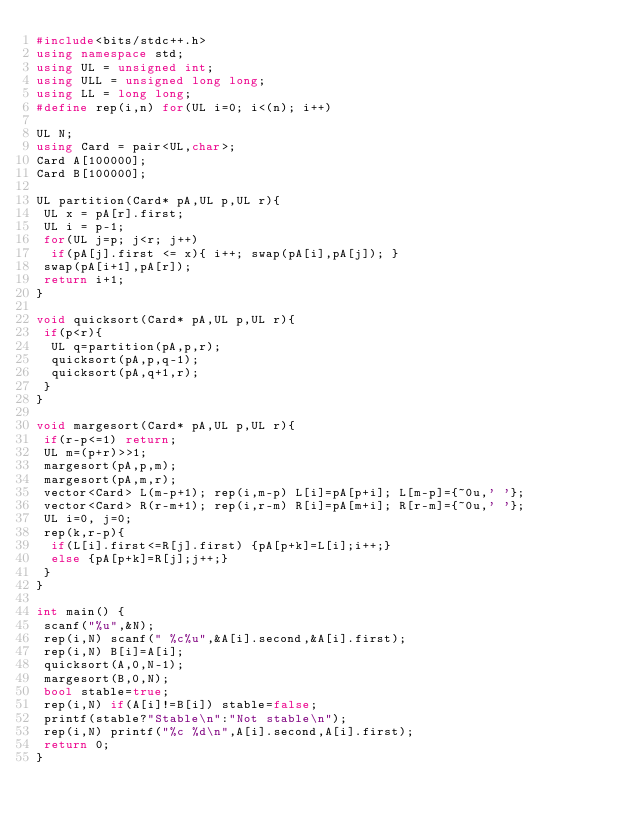<code> <loc_0><loc_0><loc_500><loc_500><_C++_>#include<bits/stdc++.h>
using namespace std;
using UL = unsigned int;
using ULL = unsigned long long;
using LL = long long;
#define rep(i,n) for(UL i=0; i<(n); i++)

UL N;
using Card = pair<UL,char>;
Card A[100000];
Card B[100000];

UL partition(Card* pA,UL p,UL r){
 UL x = pA[r].first;
 UL i = p-1;
 for(UL j=p; j<r; j++)
  if(pA[j].first <= x){ i++; swap(pA[i],pA[j]); }
 swap(pA[i+1],pA[r]);
 return i+1;
}

void quicksort(Card* pA,UL p,UL r){
 if(p<r){
  UL q=partition(pA,p,r);
  quicksort(pA,p,q-1);
  quicksort(pA,q+1,r);
 }
}

void margesort(Card* pA,UL p,UL r){
 if(r-p<=1) return;
 UL m=(p+r)>>1;
 margesort(pA,p,m);
 margesort(pA,m,r);
 vector<Card> L(m-p+1); rep(i,m-p) L[i]=pA[p+i]; L[m-p]={~0u,' '};
 vector<Card> R(r-m+1); rep(i,r-m) R[i]=pA[m+i]; R[r-m]={~0u,' '};
 UL i=0, j=0;
 rep(k,r-p){
  if(L[i].first<=R[j].first) {pA[p+k]=L[i];i++;}
  else {pA[p+k]=R[j];j++;}
 }
}

int main() {
 scanf("%u",&N);
 rep(i,N) scanf(" %c%u",&A[i].second,&A[i].first);
 rep(i,N) B[i]=A[i];
 quicksort(A,0,N-1);
 margesort(B,0,N);
 bool stable=true;
 rep(i,N) if(A[i]!=B[i]) stable=false;
 printf(stable?"Stable\n":"Not stable\n");
 rep(i,N) printf("%c %d\n",A[i].second,A[i].first);
 return 0;
}

</code> 